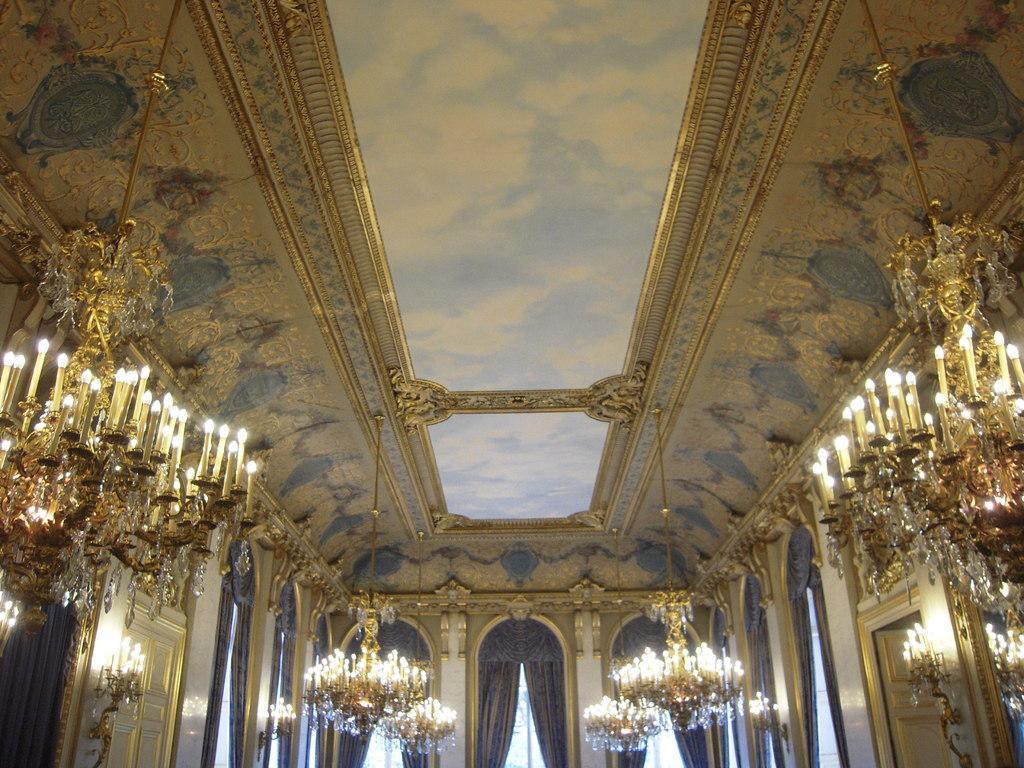Please provide a concise description of this image. The image is taken inside the building. In the center of the image there are doors and curtains. At the top there is a roof and we can see chandeliers. 